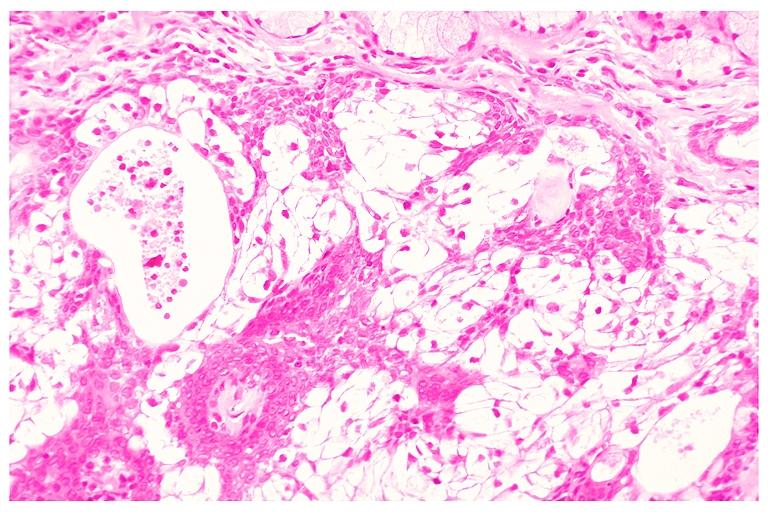s oral present?
Answer the question using a single word or phrase. Yes 